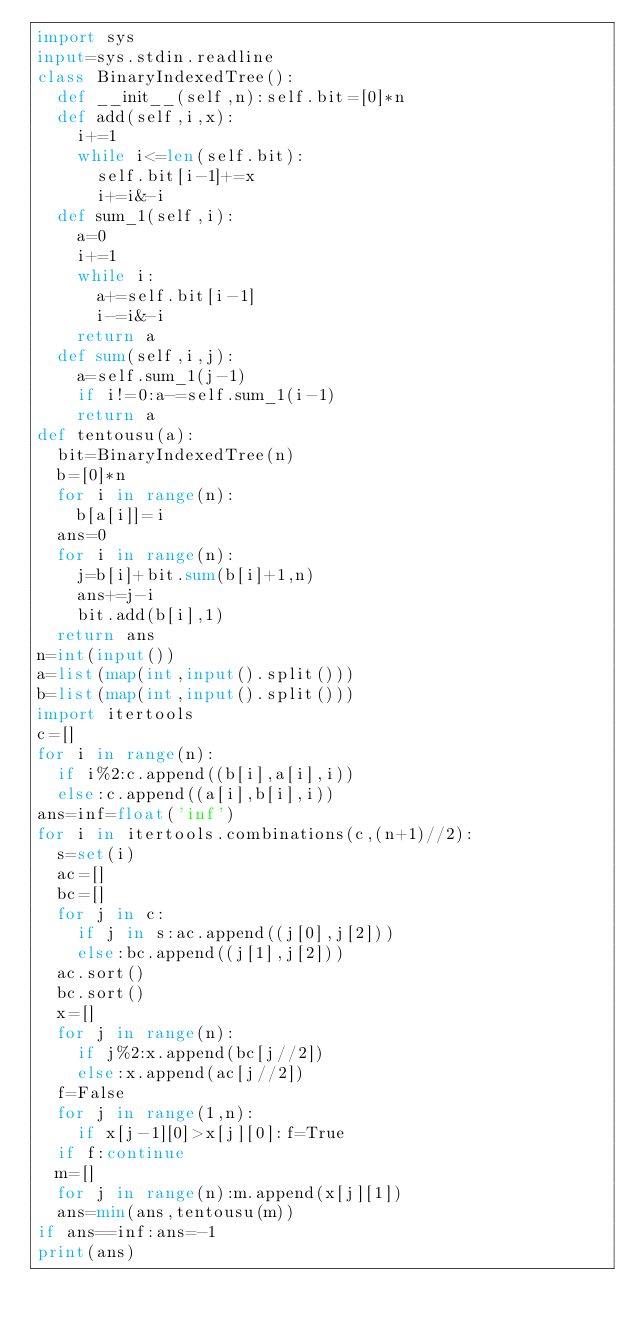Convert code to text. <code><loc_0><loc_0><loc_500><loc_500><_Python_>import sys
input=sys.stdin.readline
class BinaryIndexedTree():
  def __init__(self,n):self.bit=[0]*n
  def add(self,i,x):
    i+=1
    while i<=len(self.bit):
      self.bit[i-1]+=x
      i+=i&-i
  def sum_1(self,i):
    a=0
    i+=1
    while i:
      a+=self.bit[i-1]
      i-=i&-i
    return a
  def sum(self,i,j):
    a=self.sum_1(j-1)
    if i!=0:a-=self.sum_1(i-1)
    return a
def tentousu(a):
  bit=BinaryIndexedTree(n)
  b=[0]*n
  for i in range(n):
    b[a[i]]=i
  ans=0
  for i in range(n):
    j=b[i]+bit.sum(b[i]+1,n)
    ans+=j-i
    bit.add(b[i],1)
  return ans
n=int(input())
a=list(map(int,input().split()))
b=list(map(int,input().split()))
import itertools
c=[]
for i in range(n):
  if i%2:c.append((b[i],a[i],i))
  else:c.append((a[i],b[i],i))
ans=inf=float('inf')
for i in itertools.combinations(c,(n+1)//2):
  s=set(i)
  ac=[]
  bc=[]
  for j in c:
    if j in s:ac.append((j[0],j[2]))
    else:bc.append((j[1],j[2]))
  ac.sort()
  bc.sort()
  x=[]
  for j in range(n):
    if j%2:x.append(bc[j//2])
    else:x.append(ac[j//2])
  f=False
  for j in range(1,n):
    if x[j-1][0]>x[j][0]:f=True
  if f:continue
  m=[]
  for j in range(n):m.append(x[j][1])
  ans=min(ans,tentousu(m))
if ans==inf:ans=-1
print(ans)
</code> 